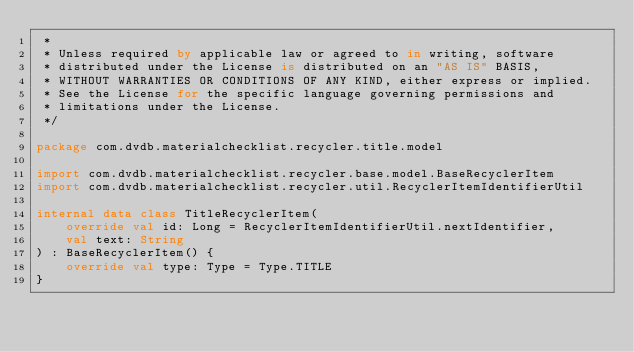<code> <loc_0><loc_0><loc_500><loc_500><_Kotlin_> *
 * Unless required by applicable law or agreed to in writing, software
 * distributed under the License is distributed on an "AS IS" BASIS,
 * WITHOUT WARRANTIES OR CONDITIONS OF ANY KIND, either express or implied.
 * See the License for the specific language governing permissions and
 * limitations under the License.
 */

package com.dvdb.materialchecklist.recycler.title.model

import com.dvdb.materialchecklist.recycler.base.model.BaseRecyclerItem
import com.dvdb.materialchecklist.recycler.util.RecyclerItemIdentifierUtil

internal data class TitleRecyclerItem(
    override val id: Long = RecyclerItemIdentifierUtil.nextIdentifier,
    val text: String
) : BaseRecyclerItem() {
    override val type: Type = Type.TITLE
}</code> 